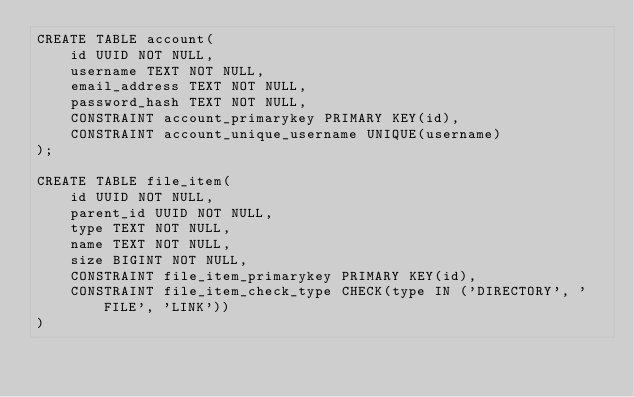<code> <loc_0><loc_0><loc_500><loc_500><_SQL_>CREATE TABLE account(
    id UUID NOT NULL,
    username TEXT NOT NULL,
    email_address TEXT NOT NULL,
    password_hash TEXT NOT NULL,
    CONSTRAINT account_primarykey PRIMARY KEY(id),
    CONSTRAINT account_unique_username UNIQUE(username)
);

CREATE TABLE file_item(
    id UUID NOT NULL,
    parent_id UUID NOT NULL,
    type TEXT NOT NULL,
    name TEXT NOT NULL,
    size BIGINT NOT NULL,
    CONSTRAINT file_item_primarykey PRIMARY KEY(id),
    CONSTRAINT file_item_check_type CHECK(type IN ('DIRECTORY', 'FILE', 'LINK'))
)
</code> 